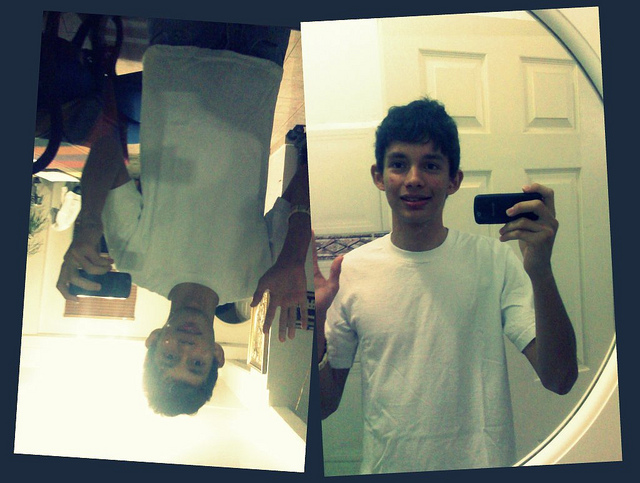Based on the objects in the photo, can you infer any possible activities or scenarios? Judging by the visible elements, the individual seems to be engaged in taking selfies. The creative use of the mirror to capture an upside-down reflection suggests a playful or artistic approach to photography. The presence of the door in the background indicates that this activity is taking place indoors, possibly in a personal space such as a bedroom. 